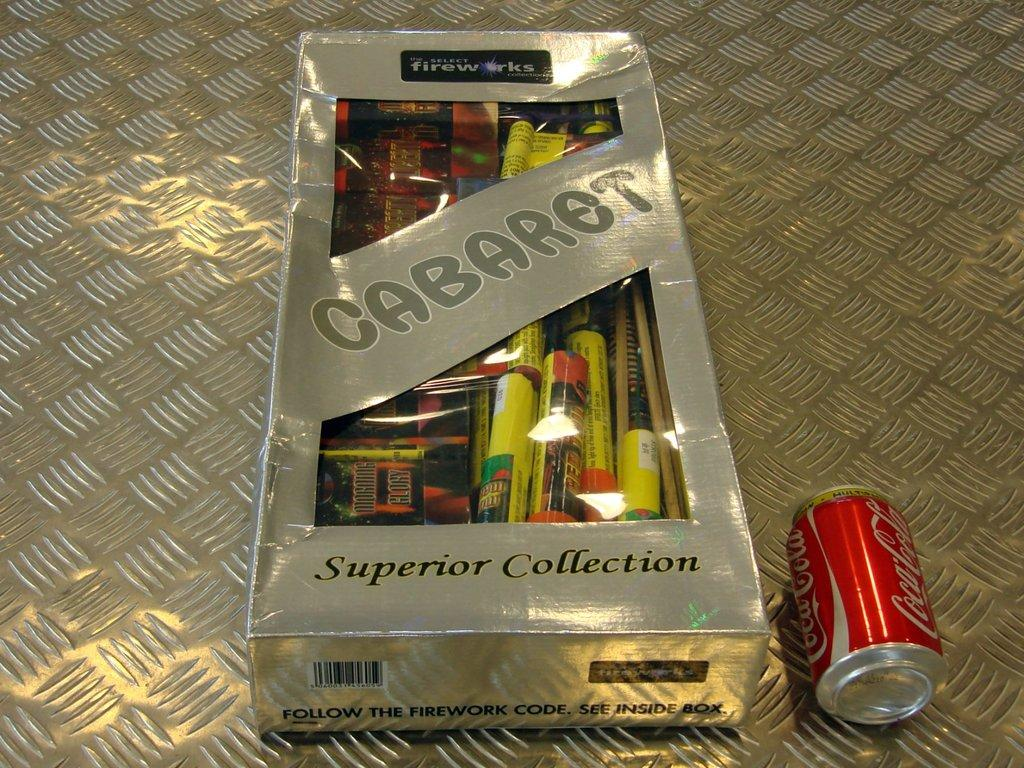<image>
Create a compact narrative representing the image presented. A can of coke lays next to a superior collection of cabaret. 